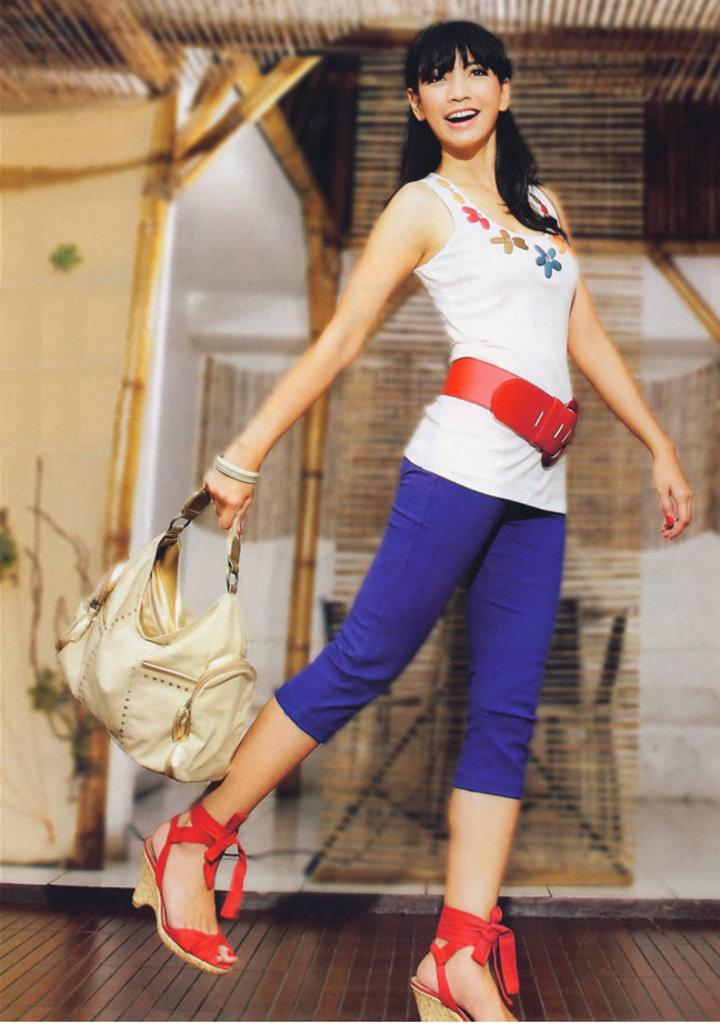Who is the main subject in the image? There is a woman in the image. What is the woman doing in the image? The woman is walking. What is the woman carrying in the image? The woman is carrying a bag. What can be seen in the background of the image? There is an architecture visible in the background of the image. How many spots can be seen on the woman's clothing in the image? There is no mention of spots on the woman's clothing in the image. Are there any feathers visible in the image? There are no feathers present in the image. 